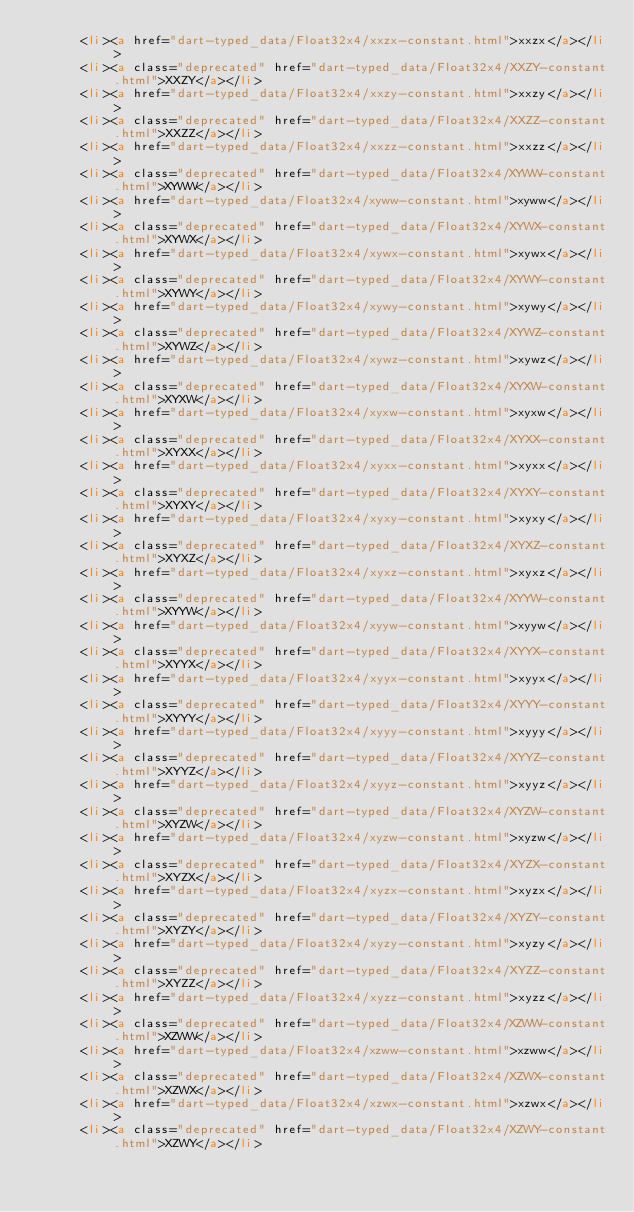<code> <loc_0><loc_0><loc_500><loc_500><_HTML_>      <li><a href="dart-typed_data/Float32x4/xxzx-constant.html">xxzx</a></li>
      <li><a class="deprecated" href="dart-typed_data/Float32x4/XXZY-constant.html">XXZY</a></li>
      <li><a href="dart-typed_data/Float32x4/xxzy-constant.html">xxzy</a></li>
      <li><a class="deprecated" href="dart-typed_data/Float32x4/XXZZ-constant.html">XXZZ</a></li>
      <li><a href="dart-typed_data/Float32x4/xxzz-constant.html">xxzz</a></li>
      <li><a class="deprecated" href="dart-typed_data/Float32x4/XYWW-constant.html">XYWW</a></li>
      <li><a href="dart-typed_data/Float32x4/xyww-constant.html">xyww</a></li>
      <li><a class="deprecated" href="dart-typed_data/Float32x4/XYWX-constant.html">XYWX</a></li>
      <li><a href="dart-typed_data/Float32x4/xywx-constant.html">xywx</a></li>
      <li><a class="deprecated" href="dart-typed_data/Float32x4/XYWY-constant.html">XYWY</a></li>
      <li><a href="dart-typed_data/Float32x4/xywy-constant.html">xywy</a></li>
      <li><a class="deprecated" href="dart-typed_data/Float32x4/XYWZ-constant.html">XYWZ</a></li>
      <li><a href="dart-typed_data/Float32x4/xywz-constant.html">xywz</a></li>
      <li><a class="deprecated" href="dart-typed_data/Float32x4/XYXW-constant.html">XYXW</a></li>
      <li><a href="dart-typed_data/Float32x4/xyxw-constant.html">xyxw</a></li>
      <li><a class="deprecated" href="dart-typed_data/Float32x4/XYXX-constant.html">XYXX</a></li>
      <li><a href="dart-typed_data/Float32x4/xyxx-constant.html">xyxx</a></li>
      <li><a class="deprecated" href="dart-typed_data/Float32x4/XYXY-constant.html">XYXY</a></li>
      <li><a href="dart-typed_data/Float32x4/xyxy-constant.html">xyxy</a></li>
      <li><a class="deprecated" href="dart-typed_data/Float32x4/XYXZ-constant.html">XYXZ</a></li>
      <li><a href="dart-typed_data/Float32x4/xyxz-constant.html">xyxz</a></li>
      <li><a class="deprecated" href="dart-typed_data/Float32x4/XYYW-constant.html">XYYW</a></li>
      <li><a href="dart-typed_data/Float32x4/xyyw-constant.html">xyyw</a></li>
      <li><a class="deprecated" href="dart-typed_data/Float32x4/XYYX-constant.html">XYYX</a></li>
      <li><a href="dart-typed_data/Float32x4/xyyx-constant.html">xyyx</a></li>
      <li><a class="deprecated" href="dart-typed_data/Float32x4/XYYY-constant.html">XYYY</a></li>
      <li><a href="dart-typed_data/Float32x4/xyyy-constant.html">xyyy</a></li>
      <li><a class="deprecated" href="dart-typed_data/Float32x4/XYYZ-constant.html">XYYZ</a></li>
      <li><a href="dart-typed_data/Float32x4/xyyz-constant.html">xyyz</a></li>
      <li><a class="deprecated" href="dart-typed_data/Float32x4/XYZW-constant.html">XYZW</a></li>
      <li><a href="dart-typed_data/Float32x4/xyzw-constant.html">xyzw</a></li>
      <li><a class="deprecated" href="dart-typed_data/Float32x4/XYZX-constant.html">XYZX</a></li>
      <li><a href="dart-typed_data/Float32x4/xyzx-constant.html">xyzx</a></li>
      <li><a class="deprecated" href="dart-typed_data/Float32x4/XYZY-constant.html">XYZY</a></li>
      <li><a href="dart-typed_data/Float32x4/xyzy-constant.html">xyzy</a></li>
      <li><a class="deprecated" href="dart-typed_data/Float32x4/XYZZ-constant.html">XYZZ</a></li>
      <li><a href="dart-typed_data/Float32x4/xyzz-constant.html">xyzz</a></li>
      <li><a class="deprecated" href="dart-typed_data/Float32x4/XZWW-constant.html">XZWW</a></li>
      <li><a href="dart-typed_data/Float32x4/xzww-constant.html">xzww</a></li>
      <li><a class="deprecated" href="dart-typed_data/Float32x4/XZWX-constant.html">XZWX</a></li>
      <li><a href="dart-typed_data/Float32x4/xzwx-constant.html">xzwx</a></li>
      <li><a class="deprecated" href="dart-typed_data/Float32x4/XZWY-constant.html">XZWY</a></li></code> 